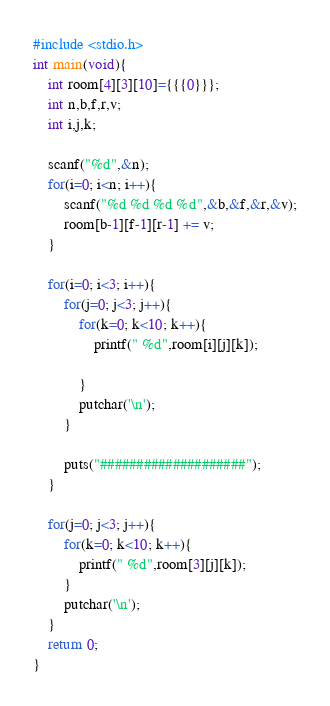<code> <loc_0><loc_0><loc_500><loc_500><_C_>#include <stdio.h>
int main(void){
    int room[4][3][10]={{{0}}};
    int n,b,f,r,v;
    int i,j,k;
    
    scanf("%d",&n);
    for(i=0; i<n; i++){
        scanf("%d %d %d %d",&b,&f,&r,&v);
        room[b-1][f-1][r-1] += v;
    }
    
    for(i=0; i<3; i++){
        for(j=0; j<3; j++){
            for(k=0; k<10; k++){
                printf(" %d",room[i][j][k]);
                
            }
            putchar('\n');
        }
    
        puts("####################");
    }
    
    for(j=0; j<3; j++){
        for(k=0; k<10; k++){
            printf(" %d",room[3][j][k]);
        }
        putchar('\n');    
    }
    return 0;
}</code> 